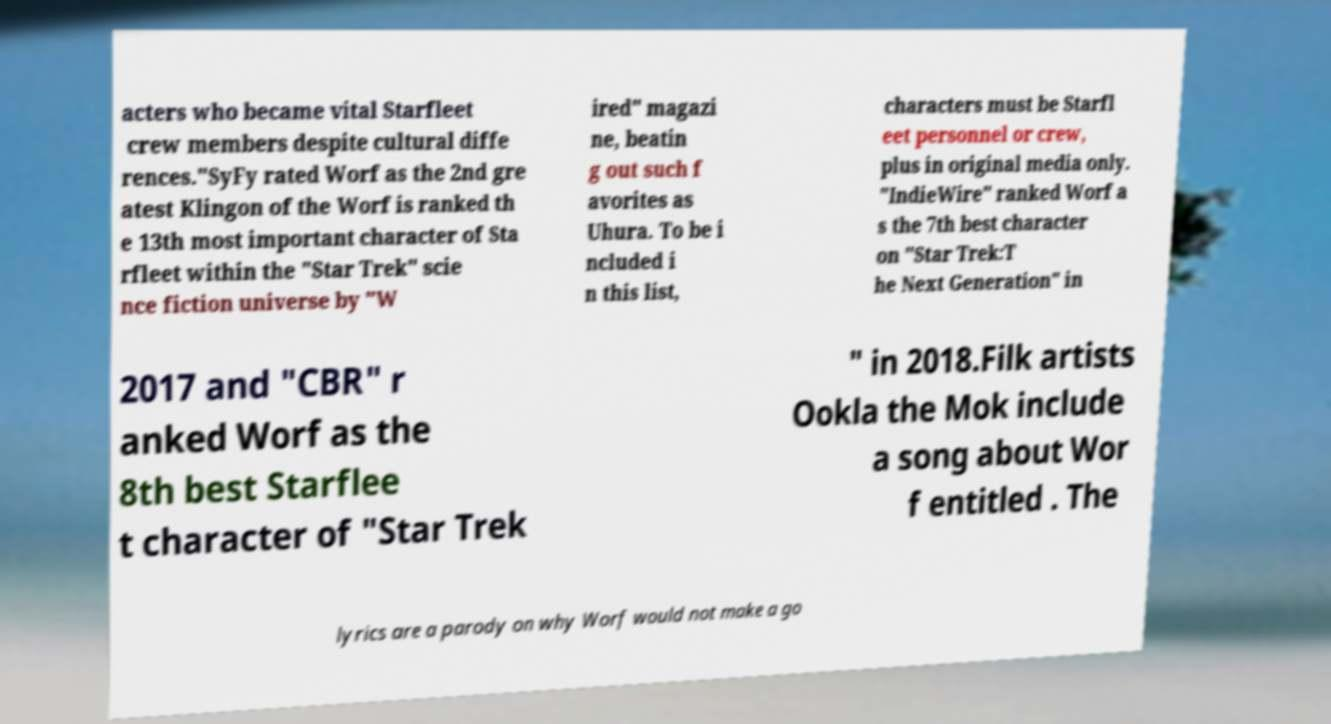Can you read and provide the text displayed in the image?This photo seems to have some interesting text. Can you extract and type it out for me? acters who became vital Starfleet crew members despite cultural diffe rences."SyFy rated Worf as the 2nd gre atest Klingon of the Worf is ranked th e 13th most important character of Sta rfleet within the "Star Trek" scie nce fiction universe by "W ired" magazi ne, beatin g out such f avorites as Uhura. To be i ncluded i n this list, characters must be Starfl eet personnel or crew, plus in original media only. "IndieWire" ranked Worf a s the 7th best character on "Star Trek:T he Next Generation" in 2017 and "CBR" r anked Worf as the 8th best Starflee t character of "Star Trek " in 2018.Filk artists Ookla the Mok include a song about Wor f entitled . The lyrics are a parody on why Worf would not make a go 